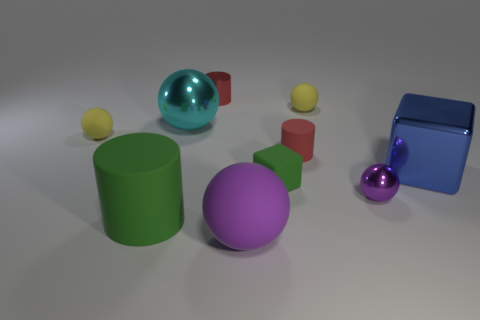What size is the object that is the same color as the tiny cube?
Give a very brief answer. Large. Is the number of tiny red metal things that are in front of the big rubber cylinder less than the number of things to the right of the big cyan metal object?
Your answer should be compact. Yes. How many blue things are either metal cubes or big matte blocks?
Your answer should be compact. 1. Are there an equal number of matte things that are in front of the blue block and purple rubber things?
Your answer should be very brief. No. What number of things are tiny cylinders or tiny objects behind the tiny green block?
Your answer should be compact. 4. Does the rubber cube have the same color as the large block?
Make the answer very short. No. Are there any other small blocks made of the same material as the tiny green cube?
Your answer should be compact. No. What color is the other metallic thing that is the same shape as the tiny green object?
Keep it short and to the point. Blue. Are the cyan sphere and the yellow ball that is right of the cyan ball made of the same material?
Provide a short and direct response. No. What is the shape of the green rubber thing behind the metal sphere on the right side of the purple matte thing?
Provide a succinct answer. Cube. 